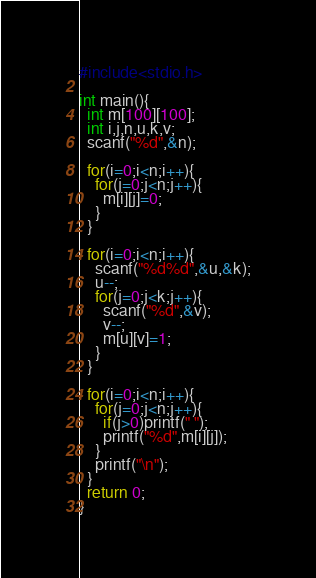<code> <loc_0><loc_0><loc_500><loc_500><_C_>#include<stdio.h>

int main(){
  int m[100][100];
  int i,j,n,u,k,v;
  scanf("%d",&n);
  
  for(i=0;i<n;i++){
    for(j=0;j<n;j++){
      m[i][j]=0;
    }
  }

  for(i=0;i<n;i++){
    scanf("%d%d",&u,&k);
    u--;
    for(j=0;j<k;j++){
      scanf("%d",&v);
      v--;
      m[u][v]=1;
    }
  }

  for(i=0;i<n;i++){
    for(j=0;j<n;j++){
      if(j>0)printf(" ");
      printf("%d",m[i][j]);
    }
    printf("\n");
  }
  return 0;
}

</code> 